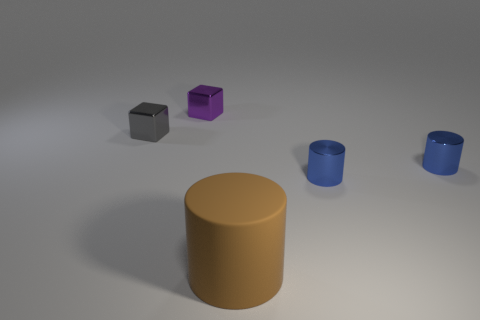Is the number of large things in front of the matte cylinder the same as the number of purple objects on the left side of the tiny purple metallic object?
Keep it short and to the point. Yes. The other metal cube that is the same size as the gray metallic block is what color?
Offer a very short reply. Purple. How many tiny objects are brown metallic things or brown objects?
Your answer should be very brief. 0. What is the material of the thing that is both right of the gray metal thing and on the left side of the brown rubber cylinder?
Provide a short and direct response. Metal. Does the metal thing that is behind the gray block have the same shape as the matte thing in front of the gray object?
Keep it short and to the point. No. What number of things are either small metallic cubes that are in front of the tiny purple cube or small purple shiny blocks?
Your answer should be very brief. 2. Is the size of the purple metallic cube the same as the rubber thing?
Give a very brief answer. No. The tiny metal block on the right side of the small gray cube is what color?
Your answer should be compact. Purple. There is a purple object that is the same material as the gray cube; what size is it?
Your response must be concise. Small. There is a gray object; does it have the same size as the brown matte thing that is in front of the tiny purple block?
Keep it short and to the point. No. 